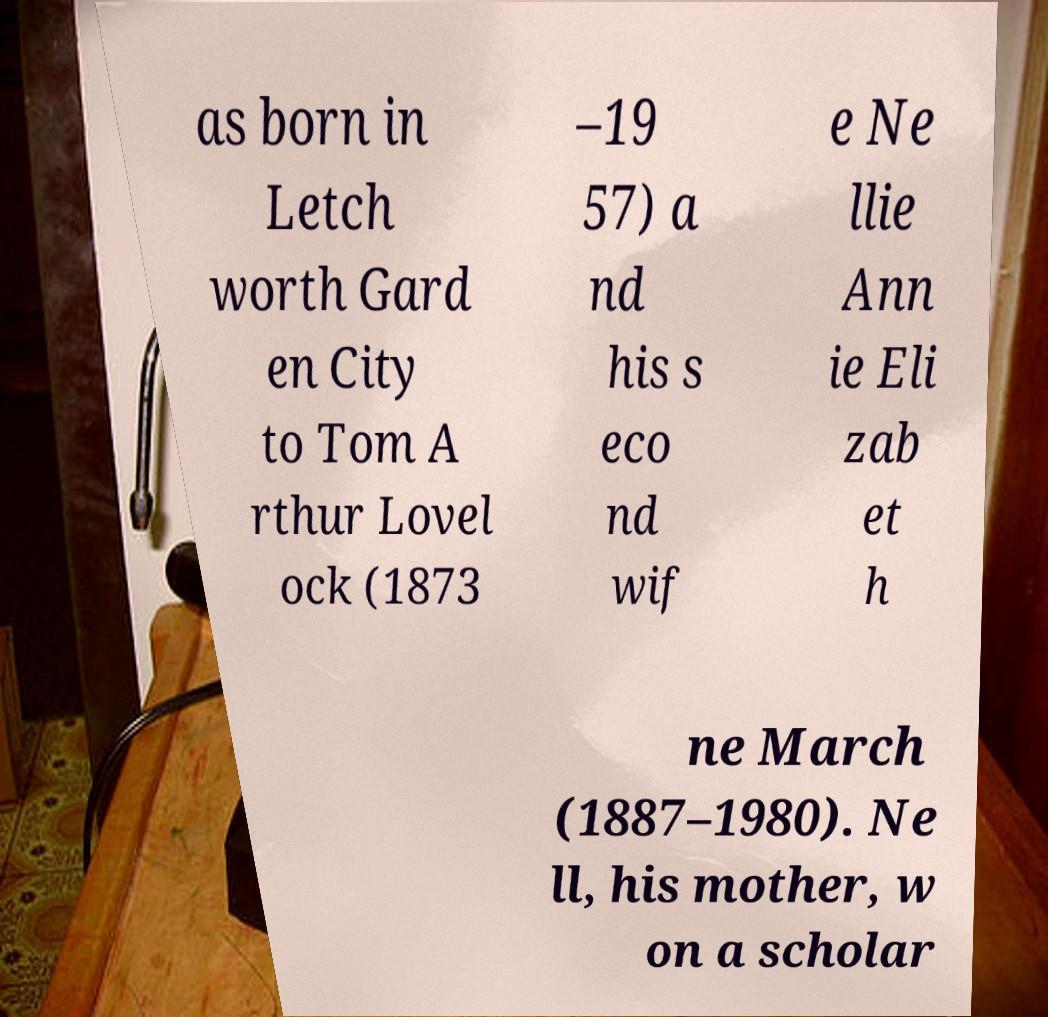Could you assist in decoding the text presented in this image and type it out clearly? as born in Letch worth Gard en City to Tom A rthur Lovel ock (1873 –19 57) a nd his s eco nd wif e Ne llie Ann ie Eli zab et h ne March (1887–1980). Ne ll, his mother, w on a scholar 